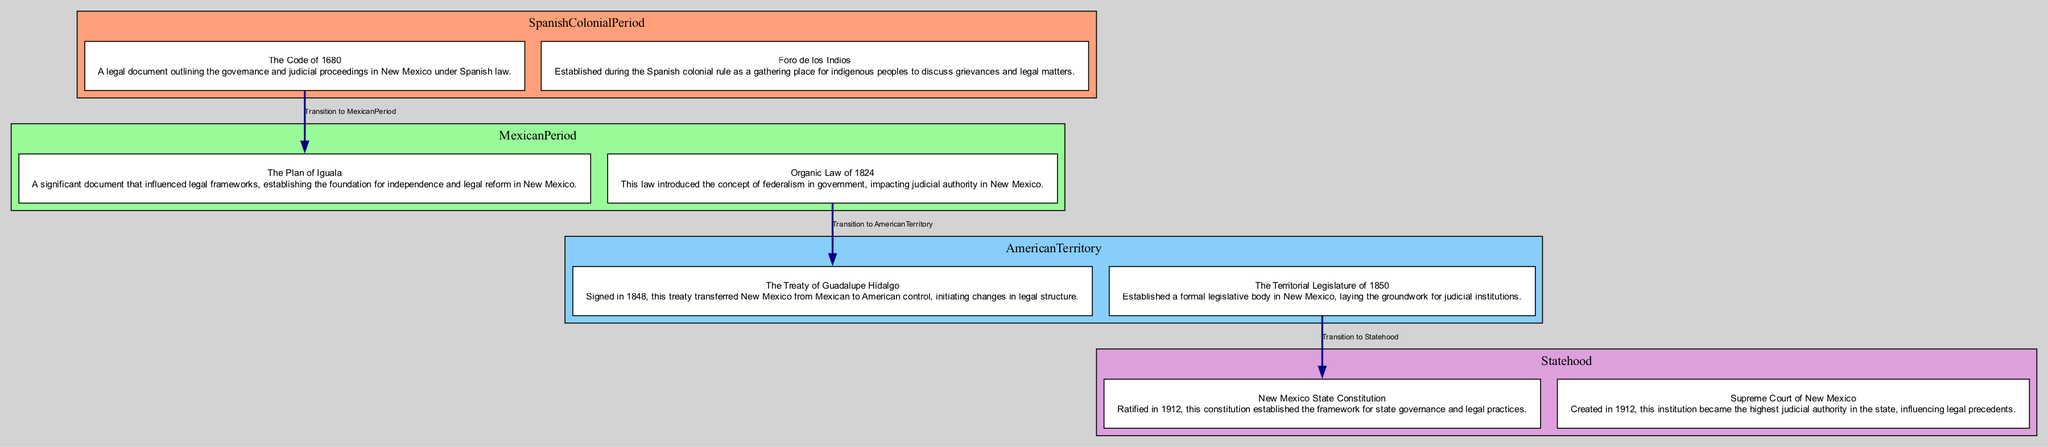What is the first legal landmark in the Spanish Colonial Period? The diagram indicates "Foro de los Indios" as the first legal landmark, which is listed as the initial element in the Spanish Colonial Period section.
Answer: Foro de los Indios How many elements are listed under the Mexican Period? The diagram displays two elements listed under the Mexican Period: "The Plan of Iguala" and "Organic Law of 1824." Therefore, the count is two.
Answer: 2 What document established a formal legislative body in New Mexico? From the diagram, "The Territorial Legislature of 1850" is the document that established a formal legislative body in New Mexico, as noted under the American Territory section.
Answer: The Territorial Legislature of 1850 Which period follows the American Territory? The diagram shows that the next step after the American Territory is "Statehood," as indicated by the arrow leading from American Territory to Statehood.
Answer: Statehood What does the New Mexico State Constitution outline? According to the diagram, the New Mexico State Constitution, ratified in 1912, established the framework for state governance and legal practices, as described in its respective section.
Answer: Framework for state governance and legal practices What is the last legal landmark in the diagram? The last legal landmark listed in the diagram is the "Supreme Court of New Mexico," which appears at the end of the Statehood section.
Answer: Supreme Court of New Mexico Which document marks the beginning of the Spanish Colonial Period? The diagram identifies "Foro de los Indios" as the beginning legal investment during the Spanish Colonial Period, appearing first in that section.
Answer: Foro de los Indios How many periods are depicted in the diagram? The diagram outlines four distinct periods: Spanish Colonial Period, Mexican Period, American Territory, and Statehood, totaling four periods overall.
Answer: 4 What transition follows the Mexican Period? The diagram indicates a transition to the American Territory following the Mexican Period, as shown by the connecting arrow.
Answer: American Territory What is a significant document from the American Territory? The diagram highlights "The Treaty of Guadalupe Hidalgo" as a significant document during the American Territory, listed as the first element in that category.
Answer: The Treaty of Guadalupe Hidalgo 